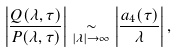Convert formula to latex. <formula><loc_0><loc_0><loc_500><loc_500>\left | \frac { Q ( \lambda , \tau ) } { P ( \lambda , \tau ) } \right | \underset { | \lambda | \to \infty } { \sim } \left | \frac { a _ { 4 } ( \tau ) } { \lambda } \right | ,</formula> 